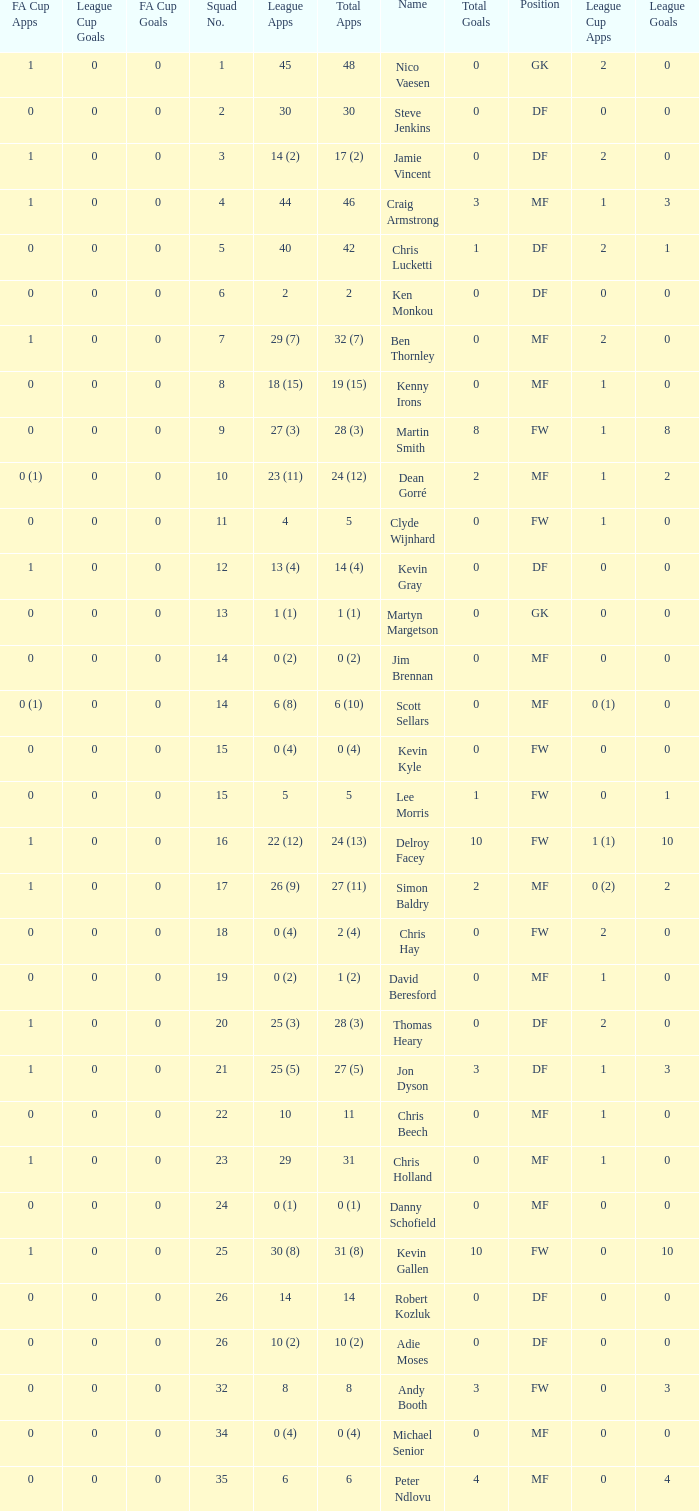Can you tell me the sum of FA Cup Goals that has the League Cup Goals larger than 0? None. 